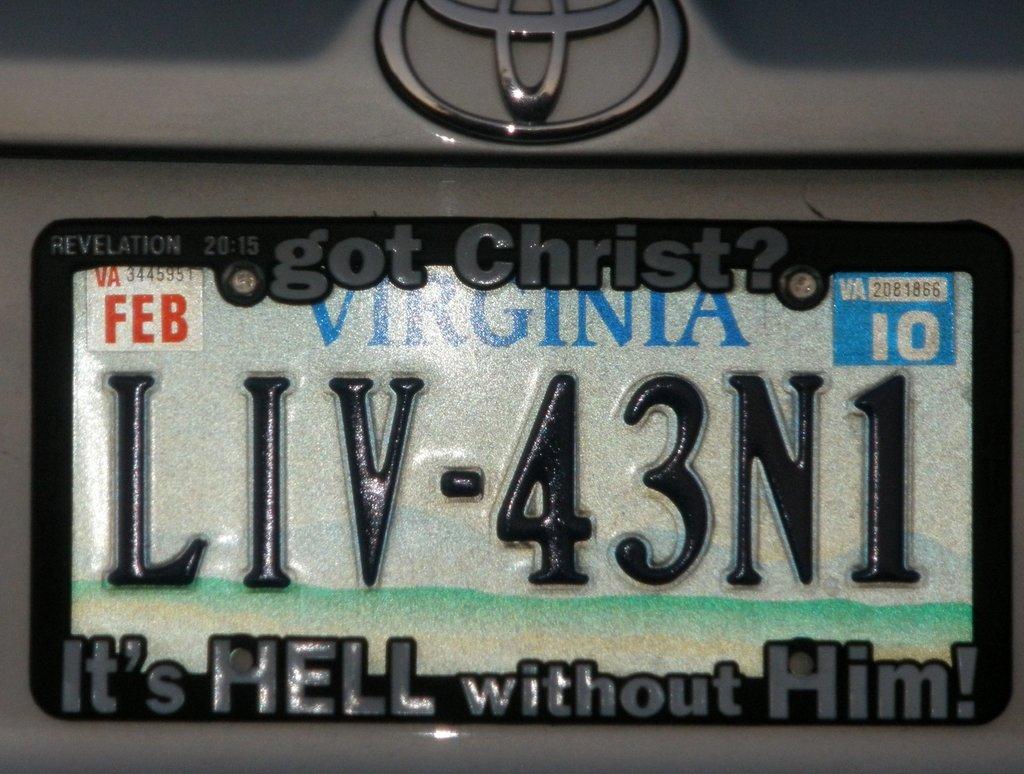What state is the car from?
Provide a succinct answer. Virginia. What month was the tag issued?
Offer a terse response. Feb. 